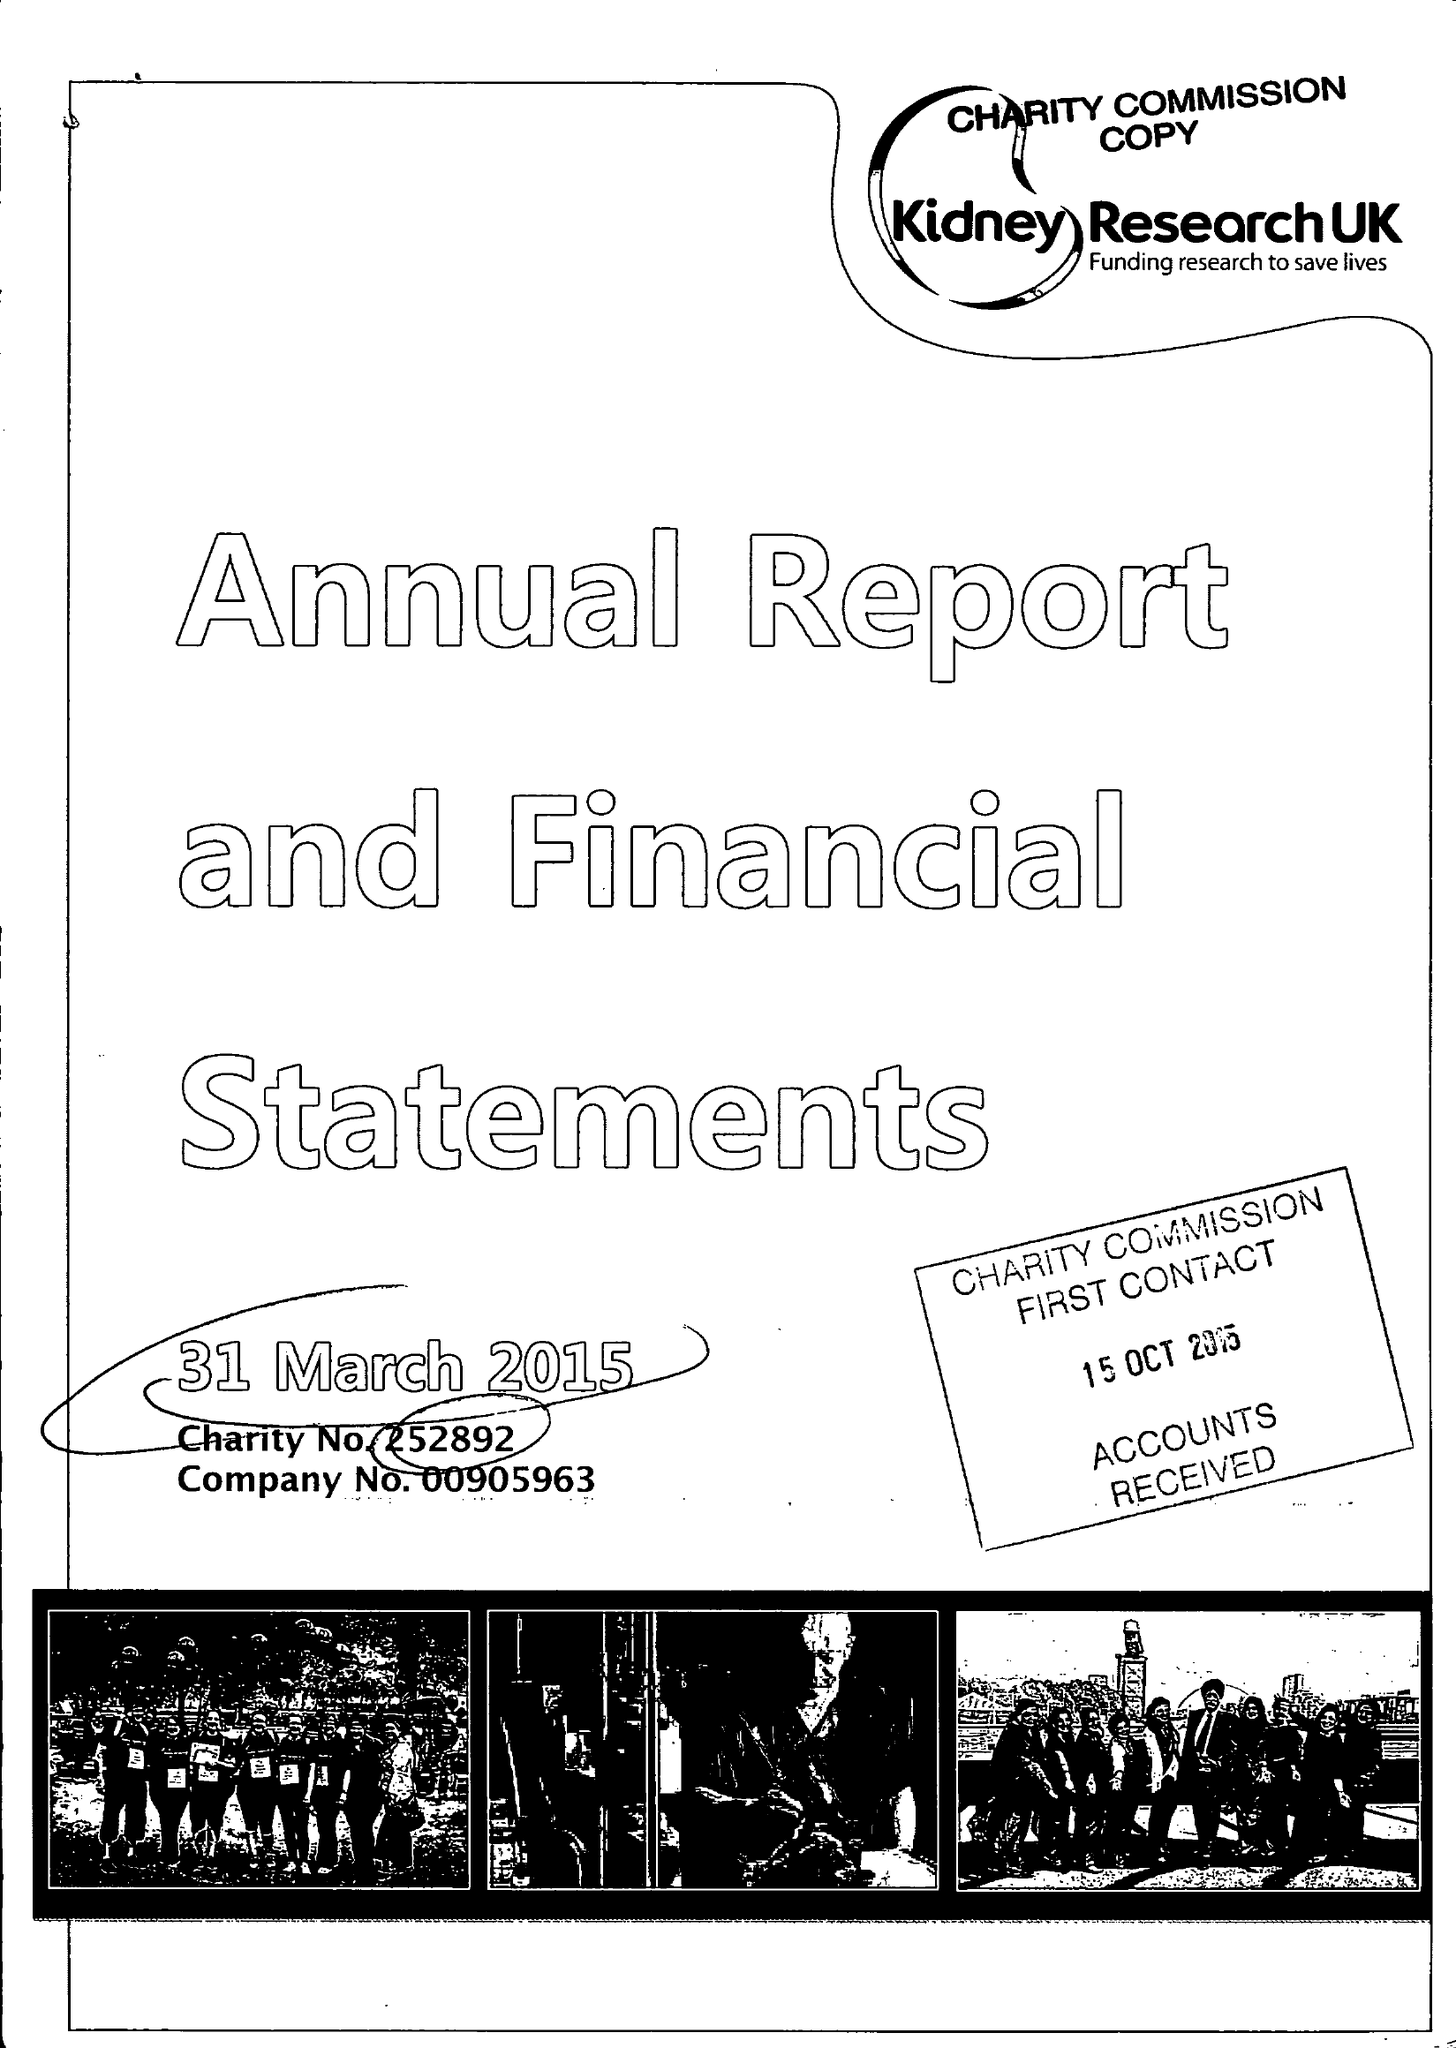What is the value for the income_annually_in_british_pounds?
Answer the question using a single word or phrase. 9160325.00 